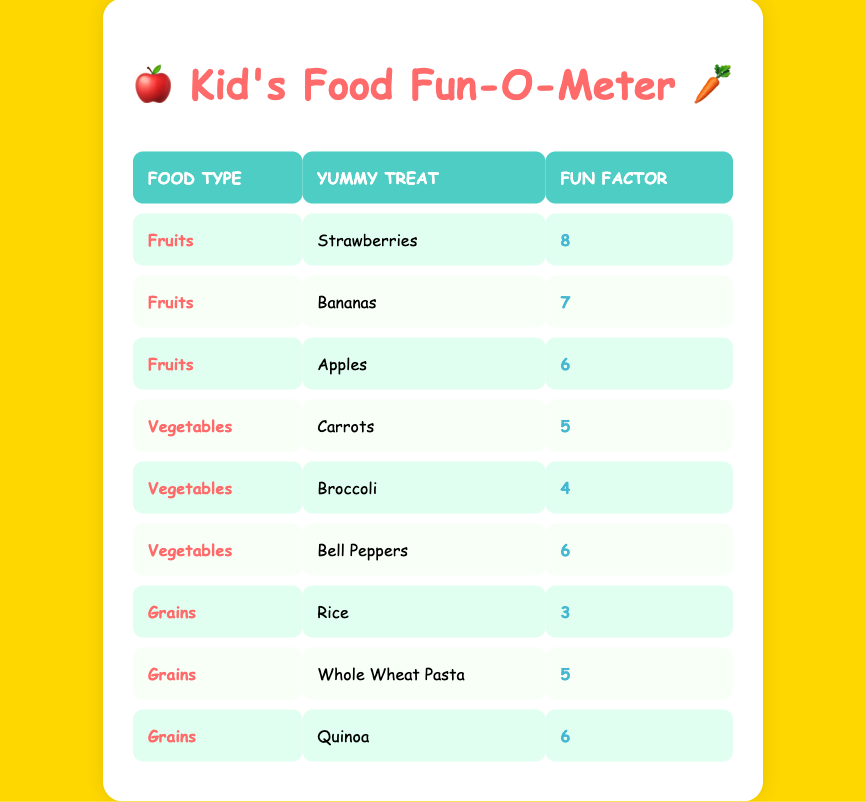What is the engagement level for bananas? The table shows bananas under the food type "Fruits" with an engagement level of 7.
Answer: 7 Which type of food has the highest engagement level? The table lists strawberries as the highest engaging food item with a level of 8 under the Fruits category.
Answer: Fruits What is the average engagement level for vegetables? The engagement levels for vegetables are 5 (Carrots), 4 (Broccoli), and 6 (Bell Peppers). Adding these levels gives a total of 15. Dividing by the number of vegetable items (3) results in an average engagement level of 5.
Answer: 5 Is the engagement level for grains higher than for vegetables? The highest engagement level for grains is 6 (Quinoa), while the highest for vegetables is 6 (Bell Peppers). They are equal, therefore it is not true that grains have a higher engagement level.
Answer: No What is the difference in engagement levels between the highest fruit and the highest vegetable? The highest engagement level for fruit is 8 (Strawberries) and for vegetables is 6 (Bell Peppers). The difference is 8 - 6 = 2.
Answer: 2 How many food items have an engagement level of 6? From the table, we identify the food items with an engagement level of 6: Strawberries (Fruits), Apples (Fruits), Bell Peppers (Vegetables), and Quinoa (Grains). This totals to 4 items.
Answer: 4 What is the total engagement level for all types of food? By summing all engagement levels (8 + 7 + 6 + 5 + 4 + 6 + 3 + 5 + 6), we get 8 + 7 = 15, 15 + 6 = 21, 21 + 5 = 26, 26 + 4 = 30, 30 + 6 = 36, 36 + 3 = 39, 39 + 5 = 44, and 44 + 6 = 50. The total engagement level for all food types is 50.
Answer: 50 Which food item has the lowest engagement level? The table shows that Rice has the lowest engagement level of 3 under the Grains category.
Answer: Rice Do all food items under the Fruits category have an engagement level of 6 or higher? The engagement levels for Fruits are 8 (Strawberries), 7 (Bananas), and 6 (Apples). Since all these levels are 6 or higher, the statement is true.
Answer: Yes 